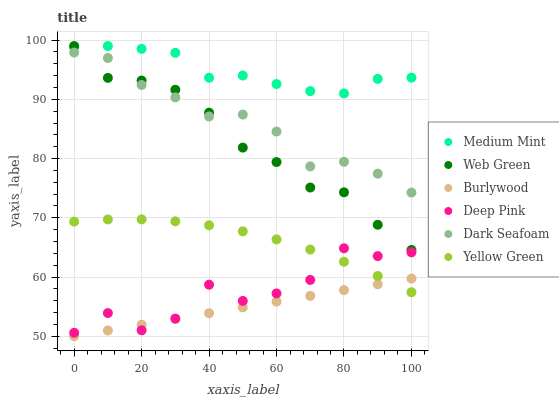Does Burlywood have the minimum area under the curve?
Answer yes or no. Yes. Does Medium Mint have the maximum area under the curve?
Answer yes or no. Yes. Does Deep Pink have the minimum area under the curve?
Answer yes or no. No. Does Deep Pink have the maximum area under the curve?
Answer yes or no. No. Is Burlywood the smoothest?
Answer yes or no. Yes. Is Deep Pink the roughest?
Answer yes or no. Yes. Is Yellow Green the smoothest?
Answer yes or no. No. Is Yellow Green the roughest?
Answer yes or no. No. Does Burlywood have the lowest value?
Answer yes or no. Yes. Does Deep Pink have the lowest value?
Answer yes or no. No. Does Web Green have the highest value?
Answer yes or no. Yes. Does Deep Pink have the highest value?
Answer yes or no. No. Is Yellow Green less than Medium Mint?
Answer yes or no. Yes. Is Medium Mint greater than Burlywood?
Answer yes or no. Yes. Does Yellow Green intersect Deep Pink?
Answer yes or no. Yes. Is Yellow Green less than Deep Pink?
Answer yes or no. No. Is Yellow Green greater than Deep Pink?
Answer yes or no. No. Does Yellow Green intersect Medium Mint?
Answer yes or no. No. 